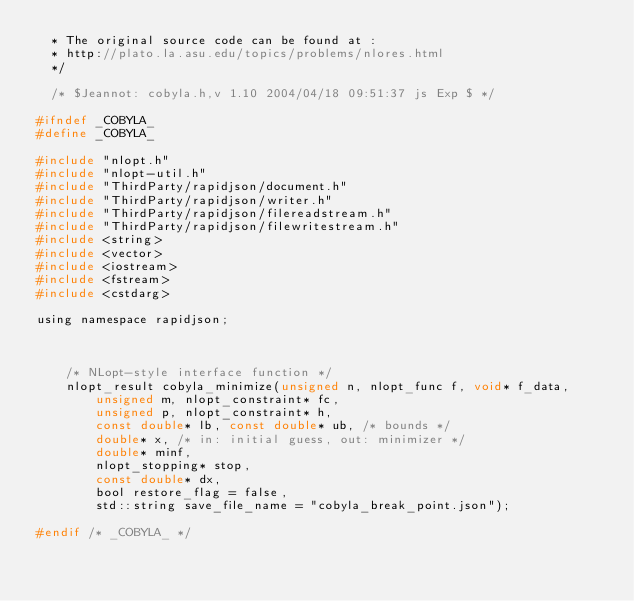<code> <loc_0><loc_0><loc_500><loc_500><_C_>  * The original source code can be found at :
  * http://plato.la.asu.edu/topics/problems/nlores.html
  */

  /* $Jeannot: cobyla.h,v 1.10 2004/04/18 09:51:37 js Exp $ */

#ifndef _COBYLA_
#define _COBYLA_

#include "nlopt.h"
#include "nlopt-util.h"
#include "ThirdParty/rapidjson/document.h"
#include "ThirdParty/rapidjson/writer.h"
#include "ThirdParty/rapidjson/filereadstream.h"
#include "ThirdParty/rapidjson/filewritestream.h"
#include <string>
#include <vector>
#include <iostream>
#include <fstream>
#include <cstdarg>

using namespace rapidjson;



    /* NLopt-style interface function */
    nlopt_result cobyla_minimize(unsigned n, nlopt_func f, void* f_data,
        unsigned m, nlopt_constraint* fc,
        unsigned p, nlopt_constraint* h,
        const double* lb, const double* ub, /* bounds */
        double* x, /* in: initial guess, out: minimizer */
        double* minf,
        nlopt_stopping* stop,
        const double* dx,
        bool restore_flag = false,
        std::string save_file_name = "cobyla_break_point.json");

#endif /* _COBYLA_ */
</code> 